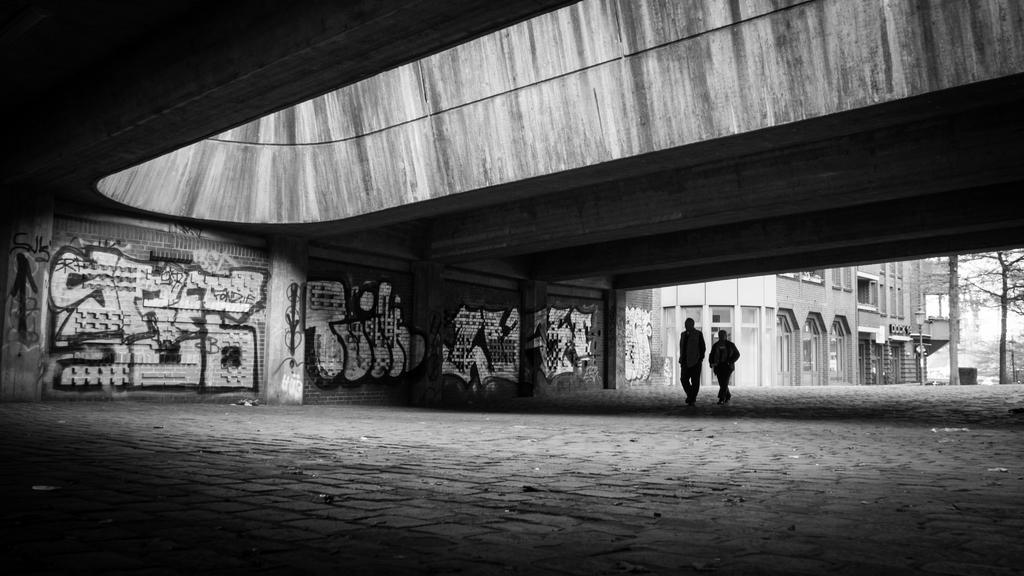How would you summarize this image in a sentence or two? In this picture we can see couple of people, beside them we can find few arts on the wall, in the background we can see a building and few trees. 